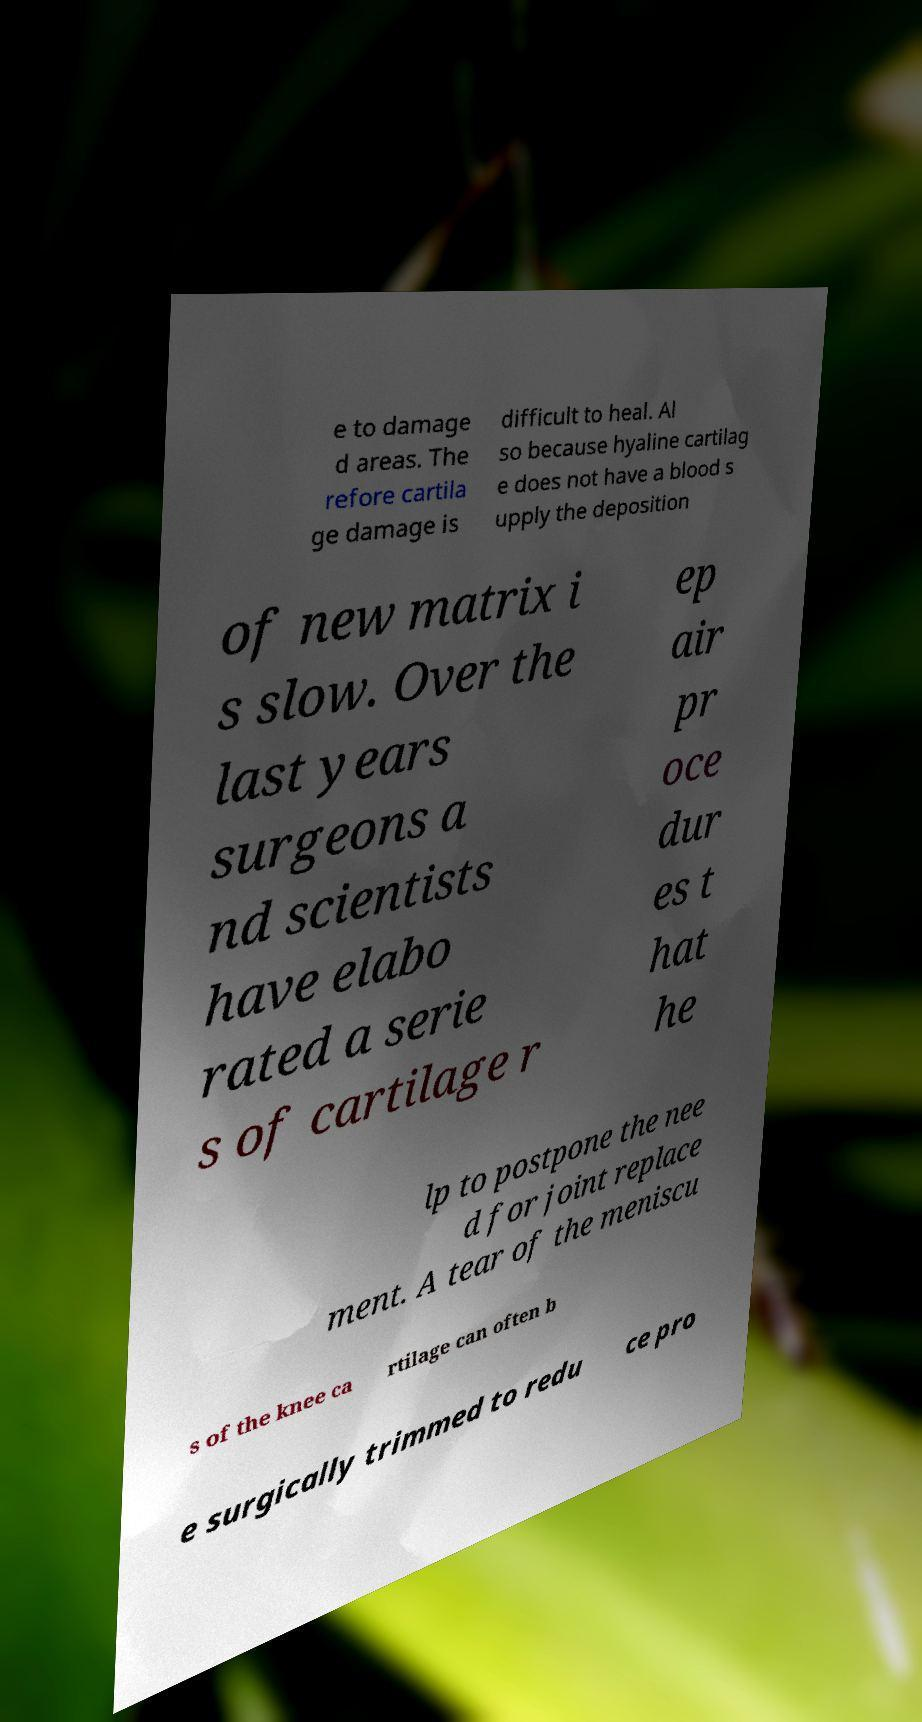Can you accurately transcribe the text from the provided image for me? e to damage d areas. The refore cartila ge damage is difficult to heal. Al so because hyaline cartilag e does not have a blood s upply the deposition of new matrix i s slow. Over the last years surgeons a nd scientists have elabo rated a serie s of cartilage r ep air pr oce dur es t hat he lp to postpone the nee d for joint replace ment. A tear of the meniscu s of the knee ca rtilage can often b e surgically trimmed to redu ce pro 